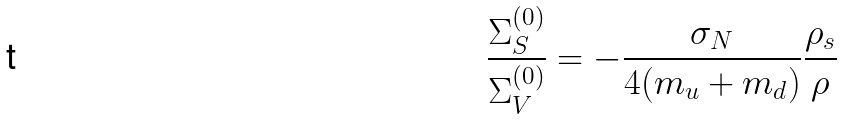<formula> <loc_0><loc_0><loc_500><loc_500>\frac { \Sigma _ { S } ^ { ( 0 ) } } { \Sigma _ { V } ^ { ( 0 ) } } = - \frac { \sigma _ { N } } { 4 ( m _ { u } + m _ { d } ) } \frac { \rho _ { s } } { \rho }</formula> 